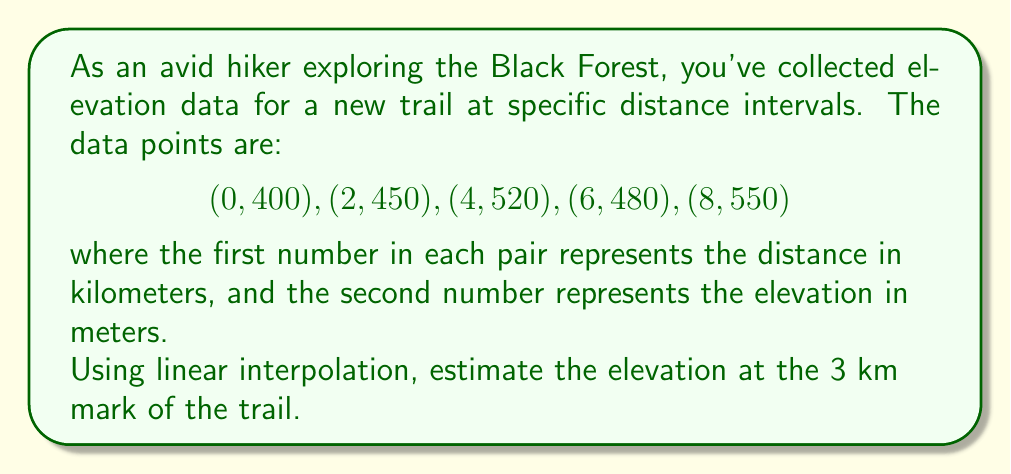Show me your answer to this math problem. Let's approach this step-by-step using linear interpolation:

1) First, we need to identify the two known data points between which our target point (3 km) lies. These are:
   $$(2, 450)$$ and $$(4, 520)$$

2) The linear interpolation formula is:

   $$y = y_1 + \frac{(x - x_1)(y_2 - y_1)}{(x_2 - x_1)}$$

   Where:
   - $(x_1, y_1)$ is the first known point: $(2, 450)$
   - $(x_2, y_2)$ is the second known point: $(4, 520)$
   - $x$ is our target x-value: $3$
   - $y$ is the elevation we're trying to find

3) Let's substitute these values into the formula:

   $$y = 450 + \frac{(3 - 2)(520 - 450)}{(4 - 2)}$$

4) Simplify:
   $$y = 450 + \frac{1 \cdot 70}{2} = 450 + 35 = 485$$

Therefore, the estimated elevation at the 3 km mark is 485 meters.
Answer: 485 meters 